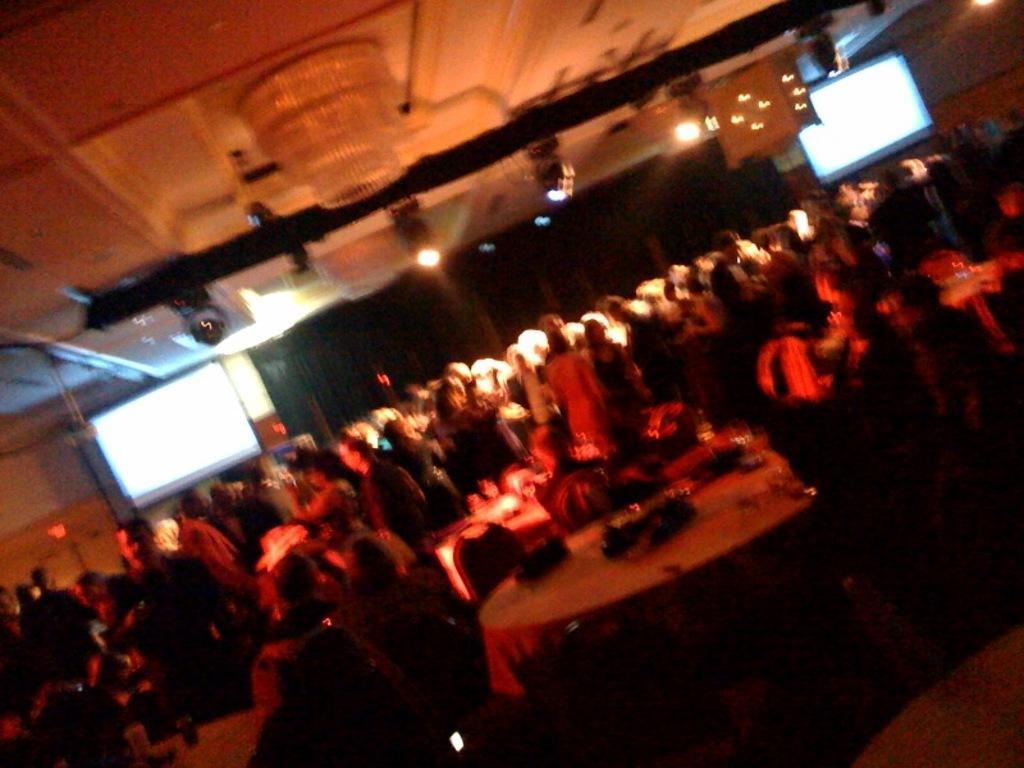Describe this image in one or two sentences. In the picture we can see a party hall with many people are standing and some people are sitting near the tables and on the table, we can see some items are placed which are not clearly visible and in the background, we can see a black curtain and with screens on both the sides on the curtain and to the ceiling we can see some lights. 